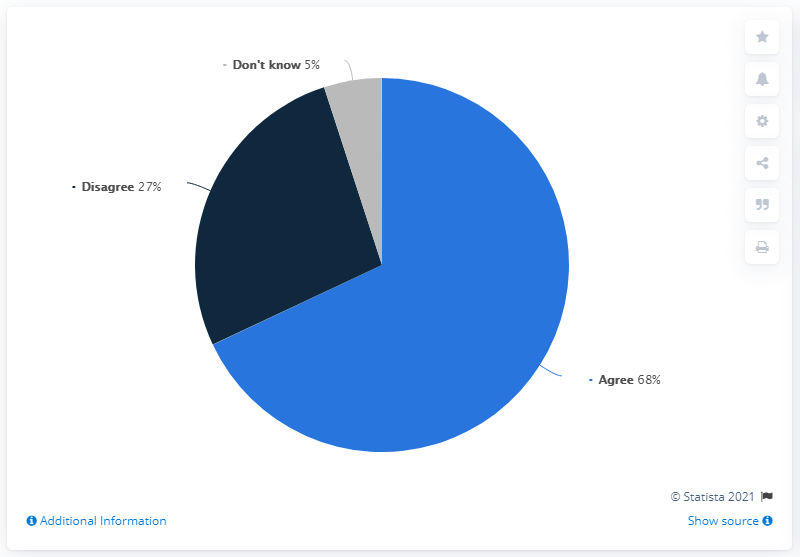Specify some key components in this picture. The poll found that there is a 41% difference between those who agree and disagree that gay, lesbian, and bisexual people should have the same rights as heterosexual people. According to a survey, a majority of people, at 68%, agree that gay, lesbian, and bisexual people should have the same rights as heterosexual people. 